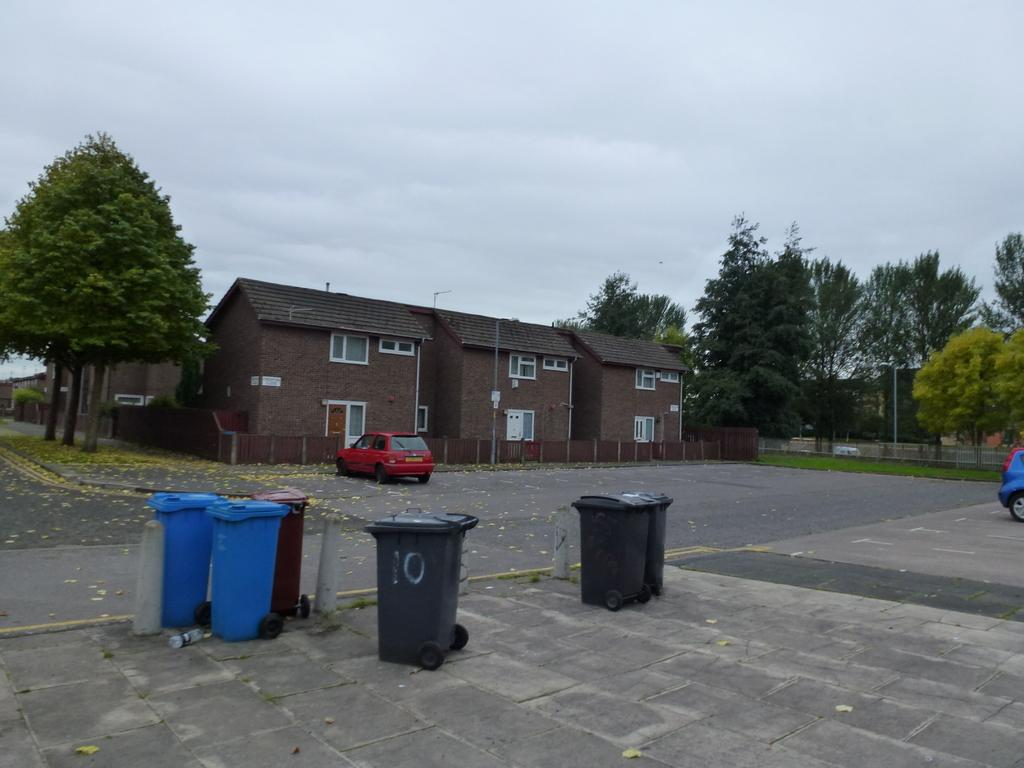Provide a one-sentence caption for the provided image. Some trash cans are sitting outside an apartment building, the closest of which has the number 10 painted on it. 